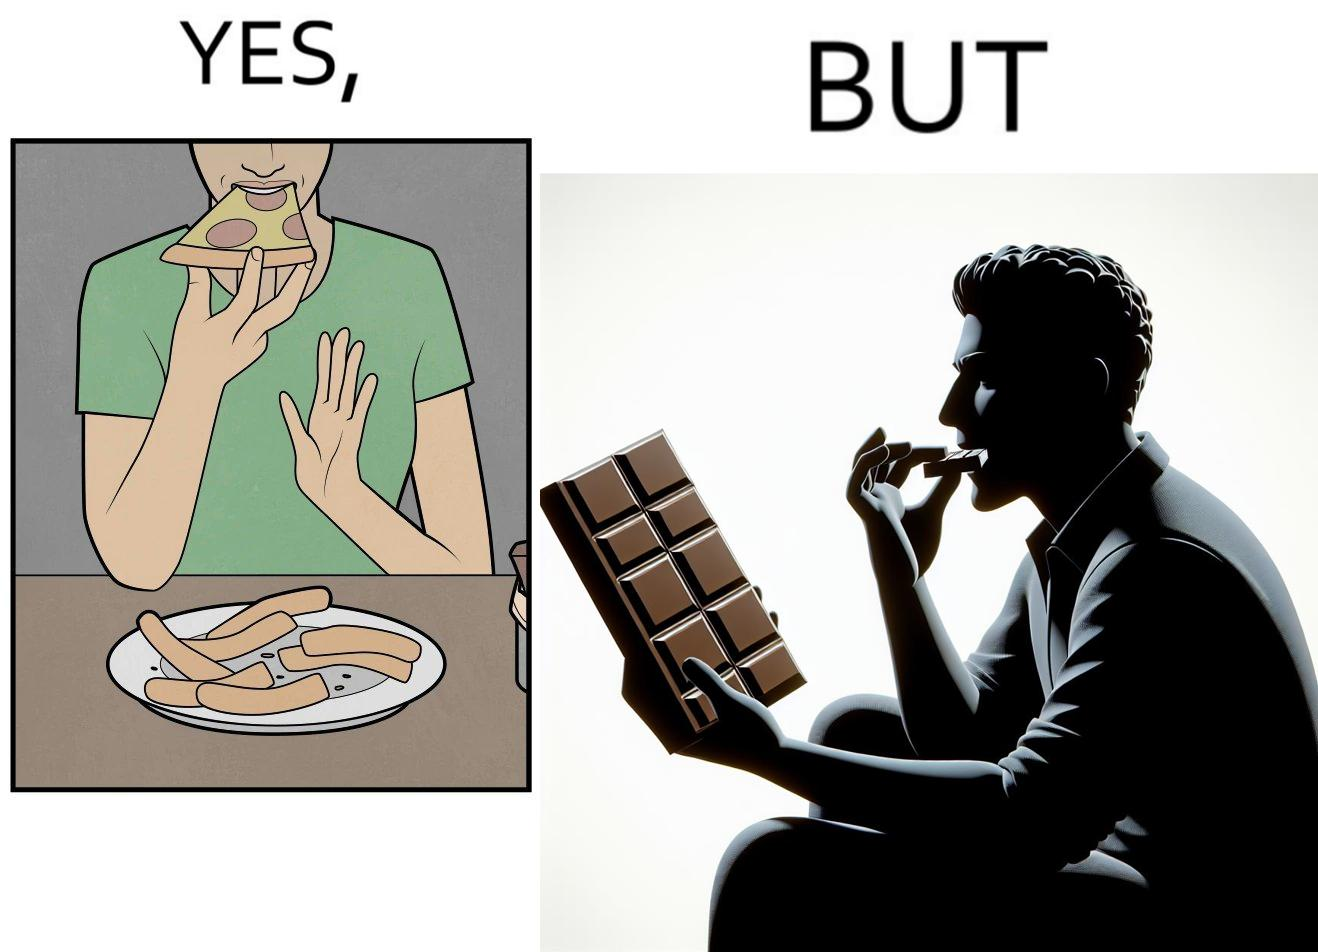Describe what you see in the left and right parts of this image. In the left part of the image: a person eating pizza and leaving the crusts on the table In the right part of the image: person eating chocolate bars 